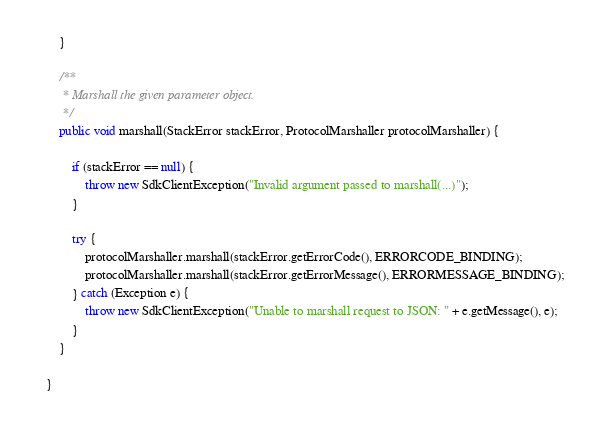<code> <loc_0><loc_0><loc_500><loc_500><_Java_>    }

    /**
     * Marshall the given parameter object.
     */
    public void marshall(StackError stackError, ProtocolMarshaller protocolMarshaller) {

        if (stackError == null) {
            throw new SdkClientException("Invalid argument passed to marshall(...)");
        }

        try {
            protocolMarshaller.marshall(stackError.getErrorCode(), ERRORCODE_BINDING);
            protocolMarshaller.marshall(stackError.getErrorMessage(), ERRORMESSAGE_BINDING);
        } catch (Exception e) {
            throw new SdkClientException("Unable to marshall request to JSON: " + e.getMessage(), e);
        }
    }

}
</code> 